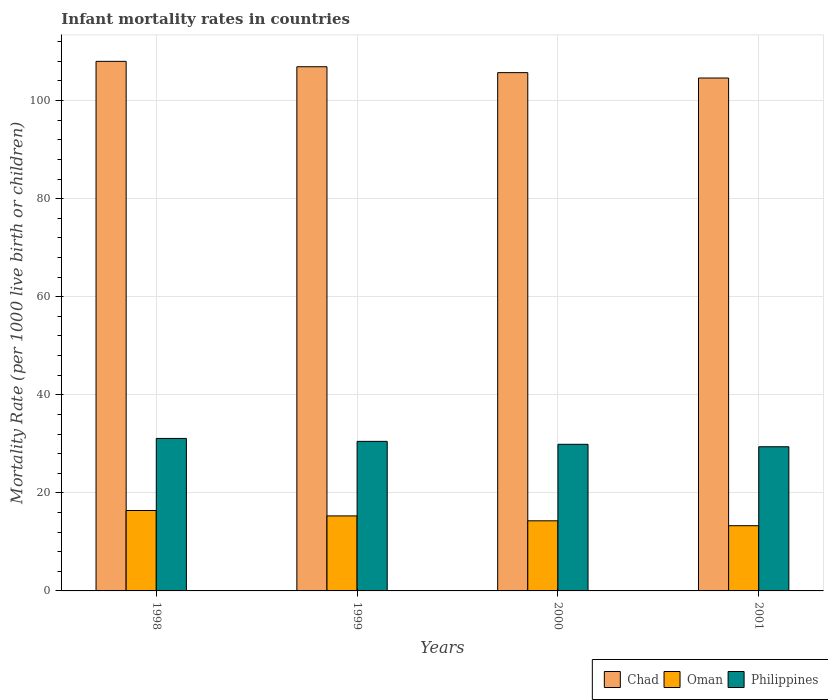Are the number of bars per tick equal to the number of legend labels?
Give a very brief answer. Yes. How many bars are there on the 1st tick from the left?
Make the answer very short. 3. How many bars are there on the 2nd tick from the right?
Offer a terse response. 3. What is the label of the 3rd group of bars from the left?
Ensure brevity in your answer.  2000. In how many cases, is the number of bars for a given year not equal to the number of legend labels?
Give a very brief answer. 0. Across all years, what is the minimum infant mortality rate in Chad?
Give a very brief answer. 104.6. In which year was the infant mortality rate in Oman minimum?
Offer a very short reply. 2001. What is the total infant mortality rate in Oman in the graph?
Provide a short and direct response. 59.3. What is the difference between the infant mortality rate in Oman in 1998 and that in 2001?
Your answer should be compact. 3.1. What is the difference between the infant mortality rate in Philippines in 2000 and the infant mortality rate in Oman in 1999?
Provide a short and direct response. 14.6. What is the average infant mortality rate in Philippines per year?
Offer a very short reply. 30.23. In the year 1998, what is the difference between the infant mortality rate in Oman and infant mortality rate in Chad?
Keep it short and to the point. -91.6. What is the ratio of the infant mortality rate in Oman in 2000 to that in 2001?
Ensure brevity in your answer.  1.08. Is the infant mortality rate in Chad in 1999 less than that in 2001?
Your answer should be compact. No. What is the difference between the highest and the second highest infant mortality rate in Chad?
Your response must be concise. 1.1. What is the difference between the highest and the lowest infant mortality rate in Philippines?
Your response must be concise. 1.7. What does the 1st bar from the right in 1998 represents?
Your answer should be very brief. Philippines. Is it the case that in every year, the sum of the infant mortality rate in Chad and infant mortality rate in Oman is greater than the infant mortality rate in Philippines?
Keep it short and to the point. Yes. How many years are there in the graph?
Your answer should be very brief. 4. Where does the legend appear in the graph?
Provide a succinct answer. Bottom right. How are the legend labels stacked?
Your response must be concise. Horizontal. What is the title of the graph?
Give a very brief answer. Infant mortality rates in countries. What is the label or title of the Y-axis?
Offer a terse response. Mortality Rate (per 1000 live birth or children). What is the Mortality Rate (per 1000 live birth or children) of Chad in 1998?
Keep it short and to the point. 108. What is the Mortality Rate (per 1000 live birth or children) of Philippines in 1998?
Offer a very short reply. 31.1. What is the Mortality Rate (per 1000 live birth or children) in Chad in 1999?
Keep it short and to the point. 106.9. What is the Mortality Rate (per 1000 live birth or children) of Oman in 1999?
Your answer should be compact. 15.3. What is the Mortality Rate (per 1000 live birth or children) of Philippines in 1999?
Offer a very short reply. 30.5. What is the Mortality Rate (per 1000 live birth or children) of Chad in 2000?
Provide a succinct answer. 105.7. What is the Mortality Rate (per 1000 live birth or children) in Oman in 2000?
Provide a succinct answer. 14.3. What is the Mortality Rate (per 1000 live birth or children) of Philippines in 2000?
Your answer should be compact. 29.9. What is the Mortality Rate (per 1000 live birth or children) of Chad in 2001?
Your response must be concise. 104.6. What is the Mortality Rate (per 1000 live birth or children) of Philippines in 2001?
Give a very brief answer. 29.4. Across all years, what is the maximum Mortality Rate (per 1000 live birth or children) in Chad?
Provide a succinct answer. 108. Across all years, what is the maximum Mortality Rate (per 1000 live birth or children) in Oman?
Provide a short and direct response. 16.4. Across all years, what is the maximum Mortality Rate (per 1000 live birth or children) of Philippines?
Offer a terse response. 31.1. Across all years, what is the minimum Mortality Rate (per 1000 live birth or children) in Chad?
Keep it short and to the point. 104.6. Across all years, what is the minimum Mortality Rate (per 1000 live birth or children) of Philippines?
Your response must be concise. 29.4. What is the total Mortality Rate (per 1000 live birth or children) in Chad in the graph?
Make the answer very short. 425.2. What is the total Mortality Rate (per 1000 live birth or children) of Oman in the graph?
Offer a very short reply. 59.3. What is the total Mortality Rate (per 1000 live birth or children) in Philippines in the graph?
Your answer should be compact. 120.9. What is the difference between the Mortality Rate (per 1000 live birth or children) of Philippines in 1998 and that in 2000?
Offer a very short reply. 1.2. What is the difference between the Mortality Rate (per 1000 live birth or children) in Philippines in 1998 and that in 2001?
Your answer should be very brief. 1.7. What is the difference between the Mortality Rate (per 1000 live birth or children) of Chad in 1999 and that in 2000?
Provide a succinct answer. 1.2. What is the difference between the Mortality Rate (per 1000 live birth or children) of Oman in 1999 and that in 2000?
Your answer should be very brief. 1. What is the difference between the Mortality Rate (per 1000 live birth or children) of Chad in 1999 and that in 2001?
Provide a succinct answer. 2.3. What is the difference between the Mortality Rate (per 1000 live birth or children) in Philippines in 1999 and that in 2001?
Make the answer very short. 1.1. What is the difference between the Mortality Rate (per 1000 live birth or children) of Oman in 2000 and that in 2001?
Ensure brevity in your answer.  1. What is the difference between the Mortality Rate (per 1000 live birth or children) of Philippines in 2000 and that in 2001?
Offer a very short reply. 0.5. What is the difference between the Mortality Rate (per 1000 live birth or children) of Chad in 1998 and the Mortality Rate (per 1000 live birth or children) of Oman in 1999?
Provide a short and direct response. 92.7. What is the difference between the Mortality Rate (per 1000 live birth or children) in Chad in 1998 and the Mortality Rate (per 1000 live birth or children) in Philippines in 1999?
Provide a succinct answer. 77.5. What is the difference between the Mortality Rate (per 1000 live birth or children) of Oman in 1998 and the Mortality Rate (per 1000 live birth or children) of Philippines in 1999?
Offer a very short reply. -14.1. What is the difference between the Mortality Rate (per 1000 live birth or children) in Chad in 1998 and the Mortality Rate (per 1000 live birth or children) in Oman in 2000?
Give a very brief answer. 93.7. What is the difference between the Mortality Rate (per 1000 live birth or children) in Chad in 1998 and the Mortality Rate (per 1000 live birth or children) in Philippines in 2000?
Offer a very short reply. 78.1. What is the difference between the Mortality Rate (per 1000 live birth or children) of Chad in 1998 and the Mortality Rate (per 1000 live birth or children) of Oman in 2001?
Offer a very short reply. 94.7. What is the difference between the Mortality Rate (per 1000 live birth or children) of Chad in 1998 and the Mortality Rate (per 1000 live birth or children) of Philippines in 2001?
Give a very brief answer. 78.6. What is the difference between the Mortality Rate (per 1000 live birth or children) in Chad in 1999 and the Mortality Rate (per 1000 live birth or children) in Oman in 2000?
Provide a succinct answer. 92.6. What is the difference between the Mortality Rate (per 1000 live birth or children) in Chad in 1999 and the Mortality Rate (per 1000 live birth or children) in Philippines in 2000?
Make the answer very short. 77. What is the difference between the Mortality Rate (per 1000 live birth or children) of Oman in 1999 and the Mortality Rate (per 1000 live birth or children) of Philippines in 2000?
Give a very brief answer. -14.6. What is the difference between the Mortality Rate (per 1000 live birth or children) of Chad in 1999 and the Mortality Rate (per 1000 live birth or children) of Oman in 2001?
Your answer should be very brief. 93.6. What is the difference between the Mortality Rate (per 1000 live birth or children) of Chad in 1999 and the Mortality Rate (per 1000 live birth or children) of Philippines in 2001?
Your answer should be compact. 77.5. What is the difference between the Mortality Rate (per 1000 live birth or children) in Oman in 1999 and the Mortality Rate (per 1000 live birth or children) in Philippines in 2001?
Your answer should be compact. -14.1. What is the difference between the Mortality Rate (per 1000 live birth or children) of Chad in 2000 and the Mortality Rate (per 1000 live birth or children) of Oman in 2001?
Keep it short and to the point. 92.4. What is the difference between the Mortality Rate (per 1000 live birth or children) in Chad in 2000 and the Mortality Rate (per 1000 live birth or children) in Philippines in 2001?
Your answer should be compact. 76.3. What is the difference between the Mortality Rate (per 1000 live birth or children) of Oman in 2000 and the Mortality Rate (per 1000 live birth or children) of Philippines in 2001?
Your answer should be compact. -15.1. What is the average Mortality Rate (per 1000 live birth or children) of Chad per year?
Provide a succinct answer. 106.3. What is the average Mortality Rate (per 1000 live birth or children) of Oman per year?
Ensure brevity in your answer.  14.82. What is the average Mortality Rate (per 1000 live birth or children) of Philippines per year?
Keep it short and to the point. 30.23. In the year 1998, what is the difference between the Mortality Rate (per 1000 live birth or children) in Chad and Mortality Rate (per 1000 live birth or children) in Oman?
Provide a succinct answer. 91.6. In the year 1998, what is the difference between the Mortality Rate (per 1000 live birth or children) in Chad and Mortality Rate (per 1000 live birth or children) in Philippines?
Offer a very short reply. 76.9. In the year 1998, what is the difference between the Mortality Rate (per 1000 live birth or children) of Oman and Mortality Rate (per 1000 live birth or children) of Philippines?
Your answer should be compact. -14.7. In the year 1999, what is the difference between the Mortality Rate (per 1000 live birth or children) of Chad and Mortality Rate (per 1000 live birth or children) of Oman?
Ensure brevity in your answer.  91.6. In the year 1999, what is the difference between the Mortality Rate (per 1000 live birth or children) of Chad and Mortality Rate (per 1000 live birth or children) of Philippines?
Make the answer very short. 76.4. In the year 1999, what is the difference between the Mortality Rate (per 1000 live birth or children) of Oman and Mortality Rate (per 1000 live birth or children) of Philippines?
Give a very brief answer. -15.2. In the year 2000, what is the difference between the Mortality Rate (per 1000 live birth or children) in Chad and Mortality Rate (per 1000 live birth or children) in Oman?
Offer a terse response. 91.4. In the year 2000, what is the difference between the Mortality Rate (per 1000 live birth or children) of Chad and Mortality Rate (per 1000 live birth or children) of Philippines?
Provide a succinct answer. 75.8. In the year 2000, what is the difference between the Mortality Rate (per 1000 live birth or children) in Oman and Mortality Rate (per 1000 live birth or children) in Philippines?
Your response must be concise. -15.6. In the year 2001, what is the difference between the Mortality Rate (per 1000 live birth or children) of Chad and Mortality Rate (per 1000 live birth or children) of Oman?
Make the answer very short. 91.3. In the year 2001, what is the difference between the Mortality Rate (per 1000 live birth or children) of Chad and Mortality Rate (per 1000 live birth or children) of Philippines?
Provide a succinct answer. 75.2. In the year 2001, what is the difference between the Mortality Rate (per 1000 live birth or children) of Oman and Mortality Rate (per 1000 live birth or children) of Philippines?
Provide a short and direct response. -16.1. What is the ratio of the Mortality Rate (per 1000 live birth or children) of Chad in 1998 to that in 1999?
Offer a very short reply. 1.01. What is the ratio of the Mortality Rate (per 1000 live birth or children) of Oman in 1998 to that in 1999?
Your answer should be compact. 1.07. What is the ratio of the Mortality Rate (per 1000 live birth or children) of Philippines in 1998 to that in 1999?
Ensure brevity in your answer.  1.02. What is the ratio of the Mortality Rate (per 1000 live birth or children) of Chad in 1998 to that in 2000?
Your response must be concise. 1.02. What is the ratio of the Mortality Rate (per 1000 live birth or children) in Oman in 1998 to that in 2000?
Make the answer very short. 1.15. What is the ratio of the Mortality Rate (per 1000 live birth or children) of Philippines in 1998 to that in 2000?
Ensure brevity in your answer.  1.04. What is the ratio of the Mortality Rate (per 1000 live birth or children) of Chad in 1998 to that in 2001?
Your answer should be very brief. 1.03. What is the ratio of the Mortality Rate (per 1000 live birth or children) in Oman in 1998 to that in 2001?
Make the answer very short. 1.23. What is the ratio of the Mortality Rate (per 1000 live birth or children) in Philippines in 1998 to that in 2001?
Give a very brief answer. 1.06. What is the ratio of the Mortality Rate (per 1000 live birth or children) in Chad in 1999 to that in 2000?
Offer a very short reply. 1.01. What is the ratio of the Mortality Rate (per 1000 live birth or children) of Oman in 1999 to that in 2000?
Your answer should be compact. 1.07. What is the ratio of the Mortality Rate (per 1000 live birth or children) in Philippines in 1999 to that in 2000?
Provide a short and direct response. 1.02. What is the ratio of the Mortality Rate (per 1000 live birth or children) of Chad in 1999 to that in 2001?
Provide a succinct answer. 1.02. What is the ratio of the Mortality Rate (per 1000 live birth or children) of Oman in 1999 to that in 2001?
Keep it short and to the point. 1.15. What is the ratio of the Mortality Rate (per 1000 live birth or children) in Philippines in 1999 to that in 2001?
Offer a terse response. 1.04. What is the ratio of the Mortality Rate (per 1000 live birth or children) in Chad in 2000 to that in 2001?
Provide a succinct answer. 1.01. What is the ratio of the Mortality Rate (per 1000 live birth or children) in Oman in 2000 to that in 2001?
Ensure brevity in your answer.  1.08. What is the difference between the highest and the second highest Mortality Rate (per 1000 live birth or children) of Chad?
Keep it short and to the point. 1.1. What is the difference between the highest and the lowest Mortality Rate (per 1000 live birth or children) in Oman?
Keep it short and to the point. 3.1. 